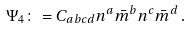Convert formula to latex. <formula><loc_0><loc_0><loc_500><loc_500>\Psi _ { 4 } \colon = C _ { a b c d } n ^ { a } { \bar { m } } ^ { b } n ^ { c } { \bar { m } } ^ { d } \, .</formula> 